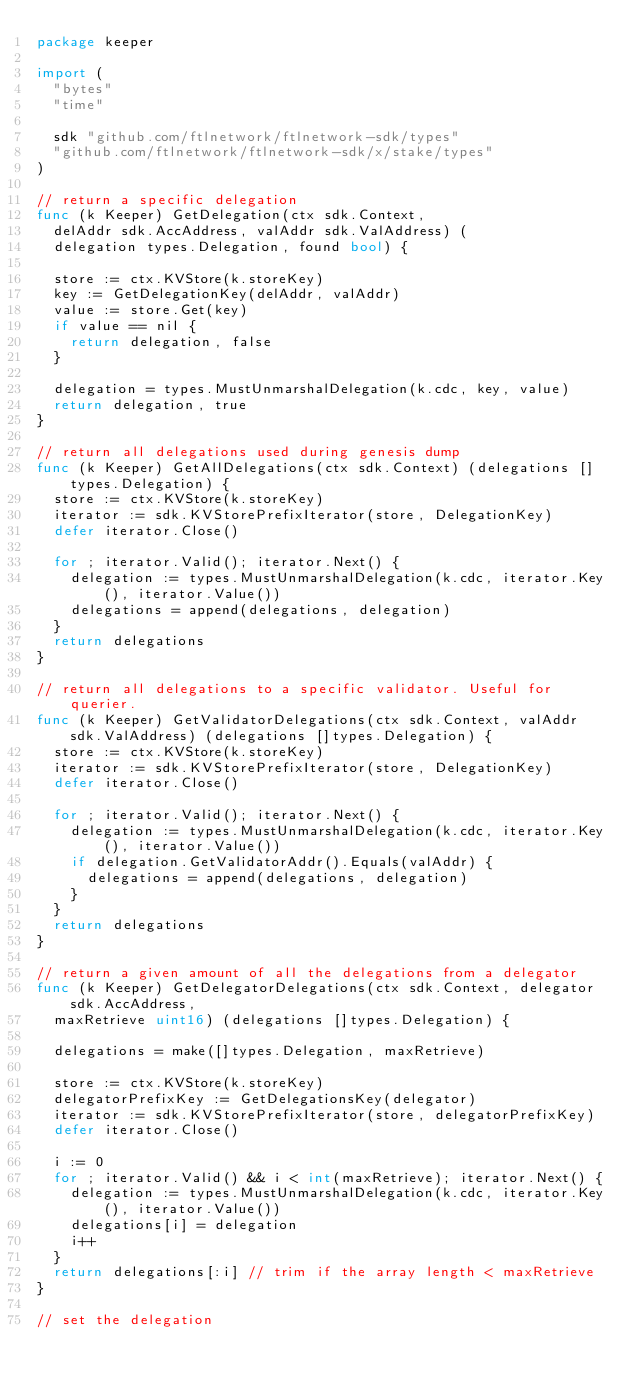<code> <loc_0><loc_0><loc_500><loc_500><_Go_>package keeper

import (
	"bytes"
	"time"

	sdk "github.com/ftlnetwork/ftlnetwork-sdk/types"
	"github.com/ftlnetwork/ftlnetwork-sdk/x/stake/types"
)

// return a specific delegation
func (k Keeper) GetDelegation(ctx sdk.Context,
	delAddr sdk.AccAddress, valAddr sdk.ValAddress) (
	delegation types.Delegation, found bool) {

	store := ctx.KVStore(k.storeKey)
	key := GetDelegationKey(delAddr, valAddr)
	value := store.Get(key)
	if value == nil {
		return delegation, false
	}

	delegation = types.MustUnmarshalDelegation(k.cdc, key, value)
	return delegation, true
}

// return all delegations used during genesis dump
func (k Keeper) GetAllDelegations(ctx sdk.Context) (delegations []types.Delegation) {
	store := ctx.KVStore(k.storeKey)
	iterator := sdk.KVStorePrefixIterator(store, DelegationKey)
	defer iterator.Close()

	for ; iterator.Valid(); iterator.Next() {
		delegation := types.MustUnmarshalDelegation(k.cdc, iterator.Key(), iterator.Value())
		delegations = append(delegations, delegation)
	}
	return delegations
}

// return all delegations to a specific validator. Useful for querier.
func (k Keeper) GetValidatorDelegations(ctx sdk.Context, valAddr sdk.ValAddress) (delegations []types.Delegation) {
	store := ctx.KVStore(k.storeKey)
	iterator := sdk.KVStorePrefixIterator(store, DelegationKey)
	defer iterator.Close()

	for ; iterator.Valid(); iterator.Next() {
		delegation := types.MustUnmarshalDelegation(k.cdc, iterator.Key(), iterator.Value())
		if delegation.GetValidatorAddr().Equals(valAddr) {
			delegations = append(delegations, delegation)
		}
	}
	return delegations
}

// return a given amount of all the delegations from a delegator
func (k Keeper) GetDelegatorDelegations(ctx sdk.Context, delegator sdk.AccAddress,
	maxRetrieve uint16) (delegations []types.Delegation) {

	delegations = make([]types.Delegation, maxRetrieve)

	store := ctx.KVStore(k.storeKey)
	delegatorPrefixKey := GetDelegationsKey(delegator)
	iterator := sdk.KVStorePrefixIterator(store, delegatorPrefixKey)
	defer iterator.Close()

	i := 0
	for ; iterator.Valid() && i < int(maxRetrieve); iterator.Next() {
		delegation := types.MustUnmarshalDelegation(k.cdc, iterator.Key(), iterator.Value())
		delegations[i] = delegation
		i++
	}
	return delegations[:i] // trim if the array length < maxRetrieve
}

// set the delegation</code> 